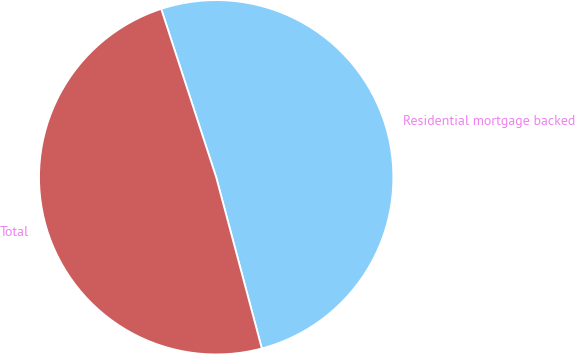Convert chart to OTSL. <chart><loc_0><loc_0><loc_500><loc_500><pie_chart><fcel>Residential mortgage backed<fcel>Total<nl><fcel>50.88%<fcel>49.12%<nl></chart> 